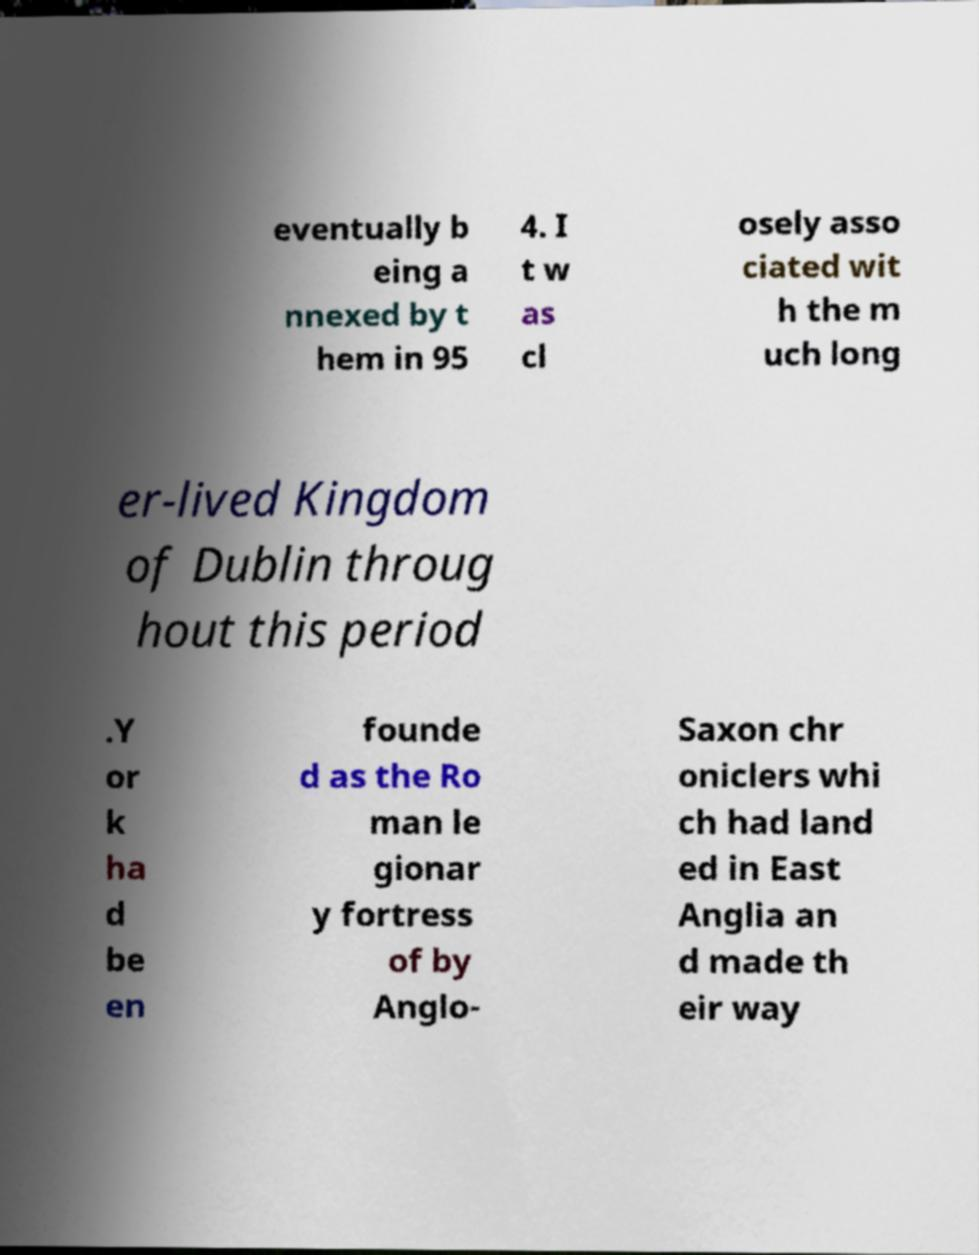Please identify and transcribe the text found in this image. eventually b eing a nnexed by t hem in 95 4. I t w as cl osely asso ciated wit h the m uch long er-lived Kingdom of Dublin throug hout this period .Y or k ha d be en founde d as the Ro man le gionar y fortress of by Anglo- Saxon chr oniclers whi ch had land ed in East Anglia an d made th eir way 